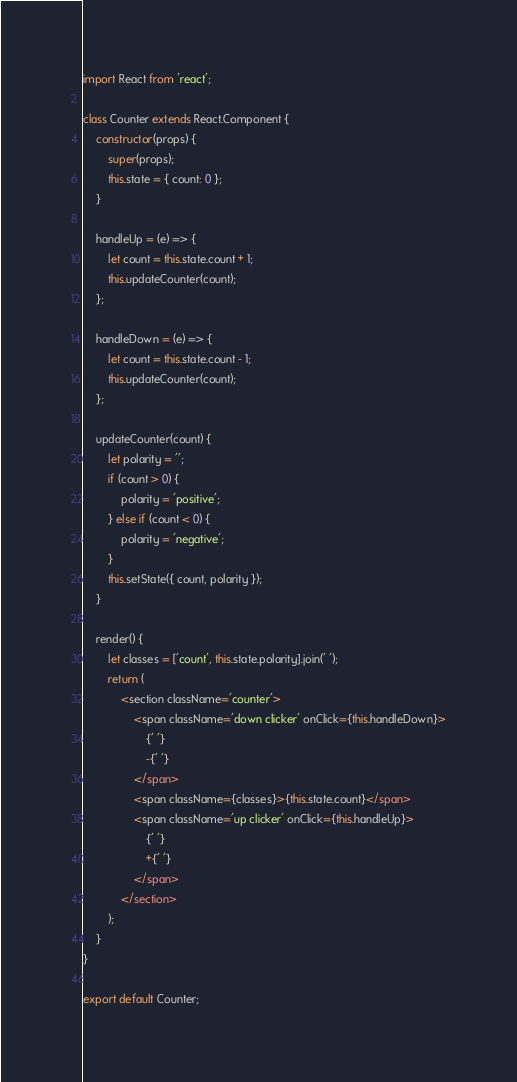Convert code to text. <code><loc_0><loc_0><loc_500><loc_500><_JavaScript_>import React from 'react';

class Counter extends React.Component {
    constructor(props) {
        super(props);
        this.state = { count: 0 };
    }

    handleUp = (e) => {
        let count = this.state.count + 1;
        this.updateCounter(count);
    };

    handleDown = (e) => {
        let count = this.state.count - 1;
        this.updateCounter(count);
    };

    updateCounter(count) {
        let polarity = '';
        if (count > 0) {
            polarity = 'positive';
        } else if (count < 0) {
            polarity = 'negative';
        }
        this.setState({ count, polarity });
    }

    render() {
        let classes = ['count', this.state.polarity].join(' ');
        return (
            <section className='counter'>
                <span className='down clicker' onClick={this.handleDown}>
                    {' '}
                    -{' '}
                </span>
                <span className={classes}>{this.state.count}</span>
                <span className='up clicker' onClick={this.handleUp}>
                    {' '}
                    +{' '}
                </span>
            </section>
        );
    }
}

export default Counter;
</code> 